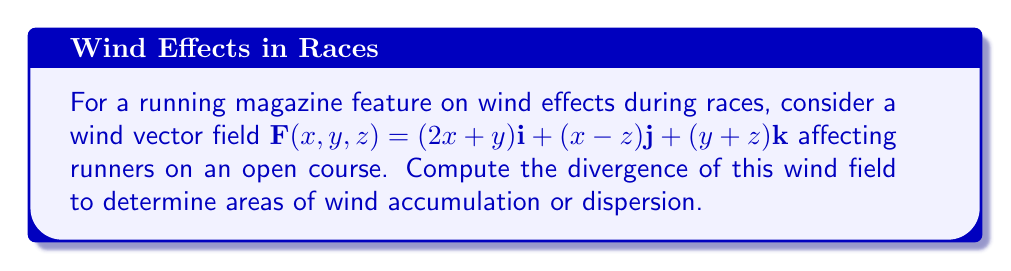Could you help me with this problem? To compute the divergence of the wind vector field, we need to follow these steps:

1. Recall the formula for divergence in 3D Cartesian coordinates:
   $$\text{div}\,\mathbf{F} = \nabla \cdot \mathbf{F} = \frac{\partial F_x}{\partial x} + \frac{\partial F_y}{\partial y} + \frac{\partial F_z}{\partial z}$$

2. Identify the components of the wind vector field:
   $F_x = 2x+y$
   $F_y = x-z$
   $F_z = y+z$

3. Calculate the partial derivatives:
   $\frac{\partial F_x}{\partial x} = \frac{\partial}{\partial x}(2x+y) = 2$
   $\frac{\partial F_y}{\partial y} = \frac{\partial}{\partial y}(x-z) = 0$
   $\frac{\partial F_z}{\partial z} = \frac{\partial}{\partial z}(y+z) = 1$

4. Sum the partial derivatives:
   $$\text{div}\,\mathbf{F} = \frac{\partial F_x}{\partial x} + \frac{\partial F_y}{\partial y} + \frac{\partial F_z}{\partial z} = 2 + 0 + 1 = 3$$

The positive divergence indicates that there is a net outflow of wind from each point in the field, which could affect runners by creating areas of wind dispersion.
Answer: $3$ 